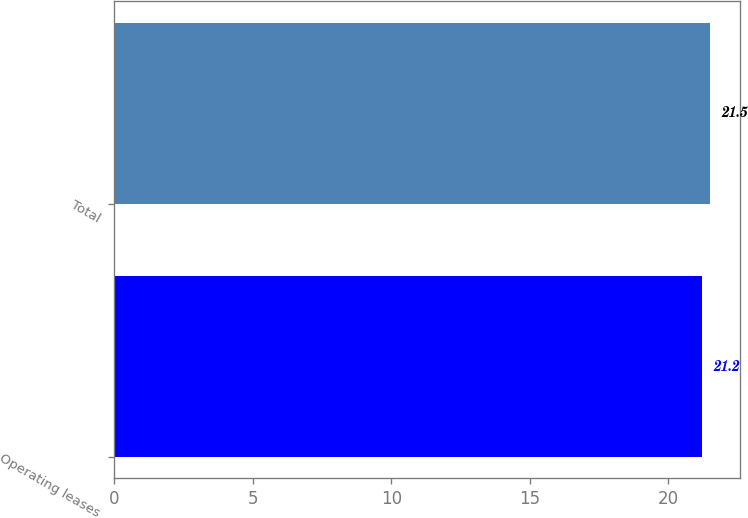Convert chart. <chart><loc_0><loc_0><loc_500><loc_500><bar_chart><fcel>Operating leases<fcel>Total<nl><fcel>21.2<fcel>21.5<nl></chart> 